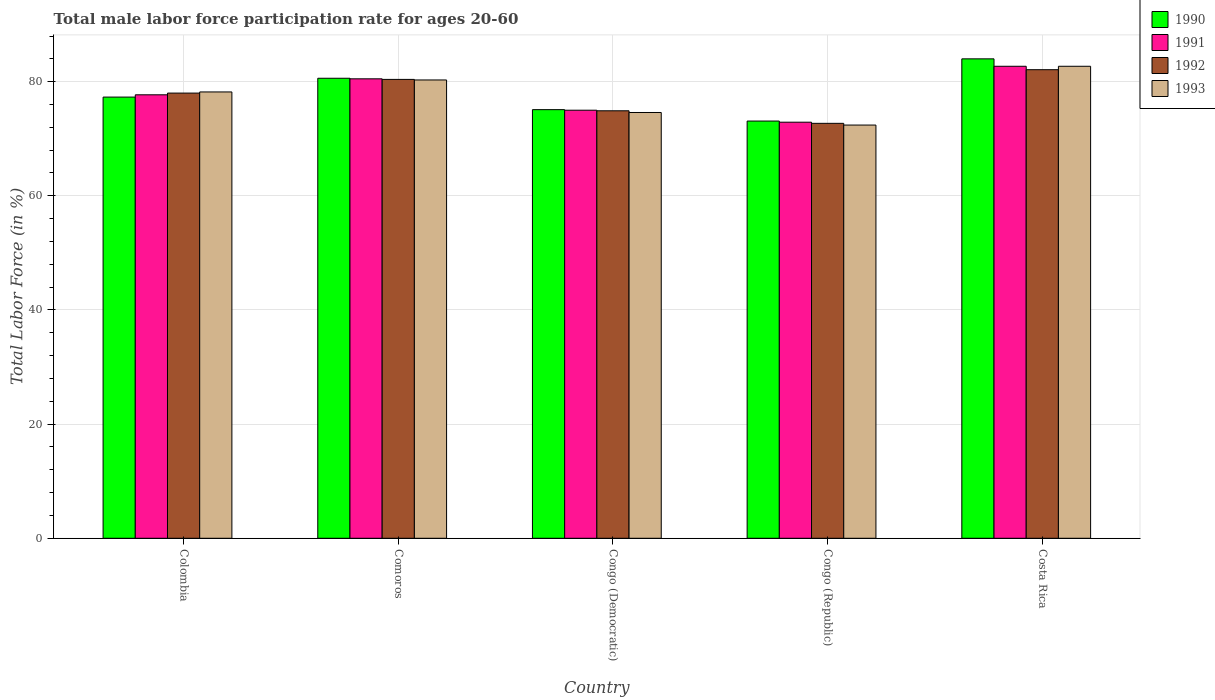How many different coloured bars are there?
Your answer should be compact. 4. How many groups of bars are there?
Your answer should be compact. 5. Are the number of bars on each tick of the X-axis equal?
Give a very brief answer. Yes. How many bars are there on the 2nd tick from the right?
Your response must be concise. 4. What is the male labor force participation rate in 1991 in Comoros?
Offer a terse response. 80.5. Across all countries, what is the minimum male labor force participation rate in 1990?
Offer a terse response. 73.1. In which country was the male labor force participation rate in 1992 maximum?
Give a very brief answer. Costa Rica. In which country was the male labor force participation rate in 1993 minimum?
Your answer should be very brief. Congo (Republic). What is the total male labor force participation rate in 1991 in the graph?
Keep it short and to the point. 388.8. What is the difference between the male labor force participation rate in 1991 in Comoros and that in Costa Rica?
Keep it short and to the point. -2.2. What is the difference between the male labor force participation rate in 1993 in Congo (Democratic) and the male labor force participation rate in 1992 in Colombia?
Your answer should be very brief. -3.4. What is the average male labor force participation rate in 1990 per country?
Make the answer very short. 78.02. In how many countries, is the male labor force participation rate in 1992 greater than 4 %?
Give a very brief answer. 5. What is the ratio of the male labor force participation rate in 1990 in Comoros to that in Congo (Republic)?
Your response must be concise. 1.1. Is the male labor force participation rate in 1993 in Colombia less than that in Congo (Democratic)?
Give a very brief answer. No. What is the difference between the highest and the second highest male labor force participation rate in 1990?
Keep it short and to the point. -3.4. What is the difference between the highest and the lowest male labor force participation rate in 1990?
Provide a short and direct response. 10.9. In how many countries, is the male labor force participation rate in 1991 greater than the average male labor force participation rate in 1991 taken over all countries?
Keep it short and to the point. 2. Is the sum of the male labor force participation rate in 1990 in Colombia and Congo (Democratic) greater than the maximum male labor force participation rate in 1992 across all countries?
Offer a terse response. Yes. Is it the case that in every country, the sum of the male labor force participation rate in 1990 and male labor force participation rate in 1993 is greater than the male labor force participation rate in 1992?
Make the answer very short. Yes. How many bars are there?
Your answer should be very brief. 20. Are all the bars in the graph horizontal?
Ensure brevity in your answer.  No. What is the difference between two consecutive major ticks on the Y-axis?
Your response must be concise. 20. Are the values on the major ticks of Y-axis written in scientific E-notation?
Your answer should be very brief. No. Where does the legend appear in the graph?
Keep it short and to the point. Top right. How many legend labels are there?
Your answer should be compact. 4. How are the legend labels stacked?
Provide a short and direct response. Vertical. What is the title of the graph?
Give a very brief answer. Total male labor force participation rate for ages 20-60. What is the label or title of the X-axis?
Provide a short and direct response. Country. What is the Total Labor Force (in %) in 1990 in Colombia?
Give a very brief answer. 77.3. What is the Total Labor Force (in %) in 1991 in Colombia?
Your answer should be very brief. 77.7. What is the Total Labor Force (in %) of 1992 in Colombia?
Your answer should be very brief. 78. What is the Total Labor Force (in %) of 1993 in Colombia?
Ensure brevity in your answer.  78.2. What is the Total Labor Force (in %) in 1990 in Comoros?
Keep it short and to the point. 80.6. What is the Total Labor Force (in %) in 1991 in Comoros?
Provide a short and direct response. 80.5. What is the Total Labor Force (in %) of 1992 in Comoros?
Keep it short and to the point. 80.4. What is the Total Labor Force (in %) of 1993 in Comoros?
Give a very brief answer. 80.3. What is the Total Labor Force (in %) of 1990 in Congo (Democratic)?
Ensure brevity in your answer.  75.1. What is the Total Labor Force (in %) of 1991 in Congo (Democratic)?
Offer a terse response. 75. What is the Total Labor Force (in %) of 1992 in Congo (Democratic)?
Your response must be concise. 74.9. What is the Total Labor Force (in %) of 1993 in Congo (Democratic)?
Provide a succinct answer. 74.6. What is the Total Labor Force (in %) of 1990 in Congo (Republic)?
Provide a succinct answer. 73.1. What is the Total Labor Force (in %) in 1991 in Congo (Republic)?
Offer a terse response. 72.9. What is the Total Labor Force (in %) in 1992 in Congo (Republic)?
Offer a very short reply. 72.7. What is the Total Labor Force (in %) of 1993 in Congo (Republic)?
Provide a succinct answer. 72.4. What is the Total Labor Force (in %) of 1991 in Costa Rica?
Provide a short and direct response. 82.7. What is the Total Labor Force (in %) of 1992 in Costa Rica?
Give a very brief answer. 82.1. What is the Total Labor Force (in %) in 1993 in Costa Rica?
Your answer should be very brief. 82.7. Across all countries, what is the maximum Total Labor Force (in %) of 1990?
Offer a very short reply. 84. Across all countries, what is the maximum Total Labor Force (in %) in 1991?
Offer a terse response. 82.7. Across all countries, what is the maximum Total Labor Force (in %) in 1992?
Provide a succinct answer. 82.1. Across all countries, what is the maximum Total Labor Force (in %) in 1993?
Keep it short and to the point. 82.7. Across all countries, what is the minimum Total Labor Force (in %) in 1990?
Make the answer very short. 73.1. Across all countries, what is the minimum Total Labor Force (in %) in 1991?
Provide a succinct answer. 72.9. Across all countries, what is the minimum Total Labor Force (in %) of 1992?
Keep it short and to the point. 72.7. Across all countries, what is the minimum Total Labor Force (in %) in 1993?
Provide a short and direct response. 72.4. What is the total Total Labor Force (in %) in 1990 in the graph?
Offer a very short reply. 390.1. What is the total Total Labor Force (in %) in 1991 in the graph?
Give a very brief answer. 388.8. What is the total Total Labor Force (in %) of 1992 in the graph?
Ensure brevity in your answer.  388.1. What is the total Total Labor Force (in %) in 1993 in the graph?
Offer a terse response. 388.2. What is the difference between the Total Labor Force (in %) in 1990 in Colombia and that in Comoros?
Give a very brief answer. -3.3. What is the difference between the Total Labor Force (in %) of 1992 in Colombia and that in Comoros?
Ensure brevity in your answer.  -2.4. What is the difference between the Total Labor Force (in %) in 1990 in Colombia and that in Congo (Democratic)?
Keep it short and to the point. 2.2. What is the difference between the Total Labor Force (in %) in 1991 in Colombia and that in Congo (Democratic)?
Your answer should be compact. 2.7. What is the difference between the Total Labor Force (in %) in 1992 in Colombia and that in Congo (Democratic)?
Provide a succinct answer. 3.1. What is the difference between the Total Labor Force (in %) of 1990 in Colombia and that in Congo (Republic)?
Your answer should be compact. 4.2. What is the difference between the Total Labor Force (in %) in 1990 in Comoros and that in Congo (Democratic)?
Provide a succinct answer. 5.5. What is the difference between the Total Labor Force (in %) in 1991 in Comoros and that in Congo (Democratic)?
Provide a short and direct response. 5.5. What is the difference between the Total Labor Force (in %) in 1992 in Comoros and that in Congo (Democratic)?
Give a very brief answer. 5.5. What is the difference between the Total Labor Force (in %) of 1993 in Comoros and that in Congo (Democratic)?
Make the answer very short. 5.7. What is the difference between the Total Labor Force (in %) in 1992 in Comoros and that in Congo (Republic)?
Provide a short and direct response. 7.7. What is the difference between the Total Labor Force (in %) of 1990 in Comoros and that in Costa Rica?
Offer a very short reply. -3.4. What is the difference between the Total Labor Force (in %) in 1992 in Comoros and that in Costa Rica?
Your answer should be very brief. -1.7. What is the difference between the Total Labor Force (in %) of 1990 in Congo (Democratic) and that in Congo (Republic)?
Your response must be concise. 2. What is the difference between the Total Labor Force (in %) of 1992 in Congo (Democratic) and that in Congo (Republic)?
Your answer should be very brief. 2.2. What is the difference between the Total Labor Force (in %) of 1991 in Congo (Democratic) and that in Costa Rica?
Make the answer very short. -7.7. What is the difference between the Total Labor Force (in %) of 1992 in Congo (Democratic) and that in Costa Rica?
Your answer should be compact. -7.2. What is the difference between the Total Labor Force (in %) of 1993 in Congo (Democratic) and that in Costa Rica?
Keep it short and to the point. -8.1. What is the difference between the Total Labor Force (in %) of 1991 in Congo (Republic) and that in Costa Rica?
Your answer should be compact. -9.8. What is the difference between the Total Labor Force (in %) of 1992 in Congo (Republic) and that in Costa Rica?
Provide a succinct answer. -9.4. What is the difference between the Total Labor Force (in %) of 1993 in Congo (Republic) and that in Costa Rica?
Make the answer very short. -10.3. What is the difference between the Total Labor Force (in %) in 1990 in Colombia and the Total Labor Force (in %) in 1991 in Comoros?
Offer a very short reply. -3.2. What is the difference between the Total Labor Force (in %) of 1990 in Colombia and the Total Labor Force (in %) of 1992 in Comoros?
Offer a terse response. -3.1. What is the difference between the Total Labor Force (in %) in 1992 in Colombia and the Total Labor Force (in %) in 1993 in Comoros?
Make the answer very short. -2.3. What is the difference between the Total Labor Force (in %) of 1990 in Colombia and the Total Labor Force (in %) of 1992 in Congo (Democratic)?
Ensure brevity in your answer.  2.4. What is the difference between the Total Labor Force (in %) in 1990 in Colombia and the Total Labor Force (in %) in 1993 in Congo (Democratic)?
Your answer should be compact. 2.7. What is the difference between the Total Labor Force (in %) of 1991 in Colombia and the Total Labor Force (in %) of 1993 in Congo (Democratic)?
Provide a succinct answer. 3.1. What is the difference between the Total Labor Force (in %) of 1990 in Colombia and the Total Labor Force (in %) of 1993 in Congo (Republic)?
Ensure brevity in your answer.  4.9. What is the difference between the Total Labor Force (in %) of 1991 in Colombia and the Total Labor Force (in %) of 1992 in Congo (Republic)?
Offer a very short reply. 5. What is the difference between the Total Labor Force (in %) of 1991 in Colombia and the Total Labor Force (in %) of 1993 in Congo (Republic)?
Ensure brevity in your answer.  5.3. What is the difference between the Total Labor Force (in %) in 1990 in Colombia and the Total Labor Force (in %) in 1992 in Costa Rica?
Your answer should be very brief. -4.8. What is the difference between the Total Labor Force (in %) of 1991 in Colombia and the Total Labor Force (in %) of 1993 in Costa Rica?
Make the answer very short. -5. What is the difference between the Total Labor Force (in %) in 1992 in Colombia and the Total Labor Force (in %) in 1993 in Costa Rica?
Your answer should be very brief. -4.7. What is the difference between the Total Labor Force (in %) in 1990 in Comoros and the Total Labor Force (in %) in 1991 in Congo (Democratic)?
Provide a short and direct response. 5.6. What is the difference between the Total Labor Force (in %) of 1990 in Comoros and the Total Labor Force (in %) of 1993 in Congo (Democratic)?
Provide a short and direct response. 6. What is the difference between the Total Labor Force (in %) of 1991 in Comoros and the Total Labor Force (in %) of 1992 in Congo (Democratic)?
Keep it short and to the point. 5.6. What is the difference between the Total Labor Force (in %) of 1991 in Comoros and the Total Labor Force (in %) of 1993 in Congo (Democratic)?
Provide a short and direct response. 5.9. What is the difference between the Total Labor Force (in %) of 1992 in Comoros and the Total Labor Force (in %) of 1993 in Congo (Democratic)?
Your response must be concise. 5.8. What is the difference between the Total Labor Force (in %) in 1990 in Comoros and the Total Labor Force (in %) in 1993 in Congo (Republic)?
Provide a succinct answer. 8.2. What is the difference between the Total Labor Force (in %) in 1992 in Comoros and the Total Labor Force (in %) in 1993 in Congo (Republic)?
Make the answer very short. 8. What is the difference between the Total Labor Force (in %) of 1991 in Comoros and the Total Labor Force (in %) of 1993 in Costa Rica?
Your response must be concise. -2.2. What is the difference between the Total Labor Force (in %) of 1992 in Comoros and the Total Labor Force (in %) of 1993 in Costa Rica?
Offer a terse response. -2.3. What is the difference between the Total Labor Force (in %) in 1990 in Congo (Democratic) and the Total Labor Force (in %) in 1992 in Congo (Republic)?
Your answer should be very brief. 2.4. What is the difference between the Total Labor Force (in %) in 1990 in Congo (Democratic) and the Total Labor Force (in %) in 1993 in Congo (Republic)?
Your answer should be very brief. 2.7. What is the difference between the Total Labor Force (in %) of 1991 in Congo (Democratic) and the Total Labor Force (in %) of 1992 in Congo (Republic)?
Your answer should be very brief. 2.3. What is the difference between the Total Labor Force (in %) in 1991 in Congo (Democratic) and the Total Labor Force (in %) in 1993 in Congo (Republic)?
Offer a very short reply. 2.6. What is the difference between the Total Labor Force (in %) of 1990 in Congo (Democratic) and the Total Labor Force (in %) of 1992 in Costa Rica?
Provide a short and direct response. -7. What is the difference between the Total Labor Force (in %) in 1990 in Congo (Democratic) and the Total Labor Force (in %) in 1993 in Costa Rica?
Give a very brief answer. -7.6. What is the difference between the Total Labor Force (in %) in 1991 in Congo (Democratic) and the Total Labor Force (in %) in 1992 in Costa Rica?
Keep it short and to the point. -7.1. What is the difference between the Total Labor Force (in %) of 1991 in Congo (Democratic) and the Total Labor Force (in %) of 1993 in Costa Rica?
Provide a short and direct response. -7.7. What is the difference between the Total Labor Force (in %) in 1992 in Congo (Democratic) and the Total Labor Force (in %) in 1993 in Costa Rica?
Keep it short and to the point. -7.8. What is the difference between the Total Labor Force (in %) of 1990 in Congo (Republic) and the Total Labor Force (in %) of 1992 in Costa Rica?
Give a very brief answer. -9. What is the difference between the Total Labor Force (in %) in 1990 in Congo (Republic) and the Total Labor Force (in %) in 1993 in Costa Rica?
Offer a terse response. -9.6. What is the average Total Labor Force (in %) of 1990 per country?
Ensure brevity in your answer.  78.02. What is the average Total Labor Force (in %) in 1991 per country?
Your response must be concise. 77.76. What is the average Total Labor Force (in %) of 1992 per country?
Provide a short and direct response. 77.62. What is the average Total Labor Force (in %) of 1993 per country?
Offer a terse response. 77.64. What is the difference between the Total Labor Force (in %) in 1991 and Total Labor Force (in %) in 1993 in Colombia?
Provide a short and direct response. -0.5. What is the difference between the Total Labor Force (in %) in 1990 and Total Labor Force (in %) in 1991 in Comoros?
Your answer should be compact. 0.1. What is the difference between the Total Labor Force (in %) in 1990 and Total Labor Force (in %) in 1993 in Comoros?
Your answer should be compact. 0.3. What is the difference between the Total Labor Force (in %) of 1990 and Total Labor Force (in %) of 1991 in Congo (Democratic)?
Your answer should be compact. 0.1. What is the difference between the Total Labor Force (in %) of 1990 and Total Labor Force (in %) of 1992 in Congo (Democratic)?
Ensure brevity in your answer.  0.2. What is the difference between the Total Labor Force (in %) in 1990 and Total Labor Force (in %) in 1993 in Congo (Democratic)?
Make the answer very short. 0.5. What is the difference between the Total Labor Force (in %) of 1991 and Total Labor Force (in %) of 1992 in Congo (Democratic)?
Give a very brief answer. 0.1. What is the difference between the Total Labor Force (in %) of 1990 and Total Labor Force (in %) of 1991 in Congo (Republic)?
Give a very brief answer. 0.2. What is the difference between the Total Labor Force (in %) of 1990 and Total Labor Force (in %) of 1993 in Congo (Republic)?
Keep it short and to the point. 0.7. What is the difference between the Total Labor Force (in %) in 1991 and Total Labor Force (in %) in 1993 in Congo (Republic)?
Keep it short and to the point. 0.5. What is the difference between the Total Labor Force (in %) in 1992 and Total Labor Force (in %) in 1993 in Congo (Republic)?
Your answer should be compact. 0.3. What is the difference between the Total Labor Force (in %) of 1990 and Total Labor Force (in %) of 1991 in Costa Rica?
Make the answer very short. 1.3. What is the ratio of the Total Labor Force (in %) of 1990 in Colombia to that in Comoros?
Give a very brief answer. 0.96. What is the ratio of the Total Labor Force (in %) of 1991 in Colombia to that in Comoros?
Provide a succinct answer. 0.97. What is the ratio of the Total Labor Force (in %) in 1992 in Colombia to that in Comoros?
Keep it short and to the point. 0.97. What is the ratio of the Total Labor Force (in %) of 1993 in Colombia to that in Comoros?
Offer a very short reply. 0.97. What is the ratio of the Total Labor Force (in %) in 1990 in Colombia to that in Congo (Democratic)?
Provide a short and direct response. 1.03. What is the ratio of the Total Labor Force (in %) in 1991 in Colombia to that in Congo (Democratic)?
Your answer should be compact. 1.04. What is the ratio of the Total Labor Force (in %) of 1992 in Colombia to that in Congo (Democratic)?
Offer a very short reply. 1.04. What is the ratio of the Total Labor Force (in %) in 1993 in Colombia to that in Congo (Democratic)?
Offer a very short reply. 1.05. What is the ratio of the Total Labor Force (in %) in 1990 in Colombia to that in Congo (Republic)?
Provide a succinct answer. 1.06. What is the ratio of the Total Labor Force (in %) in 1991 in Colombia to that in Congo (Republic)?
Give a very brief answer. 1.07. What is the ratio of the Total Labor Force (in %) of 1992 in Colombia to that in Congo (Republic)?
Give a very brief answer. 1.07. What is the ratio of the Total Labor Force (in %) of 1993 in Colombia to that in Congo (Republic)?
Offer a terse response. 1.08. What is the ratio of the Total Labor Force (in %) in 1990 in Colombia to that in Costa Rica?
Keep it short and to the point. 0.92. What is the ratio of the Total Labor Force (in %) of 1991 in Colombia to that in Costa Rica?
Your answer should be compact. 0.94. What is the ratio of the Total Labor Force (in %) of 1992 in Colombia to that in Costa Rica?
Your answer should be compact. 0.95. What is the ratio of the Total Labor Force (in %) in 1993 in Colombia to that in Costa Rica?
Keep it short and to the point. 0.95. What is the ratio of the Total Labor Force (in %) of 1990 in Comoros to that in Congo (Democratic)?
Keep it short and to the point. 1.07. What is the ratio of the Total Labor Force (in %) in 1991 in Comoros to that in Congo (Democratic)?
Offer a terse response. 1.07. What is the ratio of the Total Labor Force (in %) in 1992 in Comoros to that in Congo (Democratic)?
Your response must be concise. 1.07. What is the ratio of the Total Labor Force (in %) in 1993 in Comoros to that in Congo (Democratic)?
Provide a succinct answer. 1.08. What is the ratio of the Total Labor Force (in %) in 1990 in Comoros to that in Congo (Republic)?
Provide a short and direct response. 1.1. What is the ratio of the Total Labor Force (in %) in 1991 in Comoros to that in Congo (Republic)?
Provide a succinct answer. 1.1. What is the ratio of the Total Labor Force (in %) of 1992 in Comoros to that in Congo (Republic)?
Keep it short and to the point. 1.11. What is the ratio of the Total Labor Force (in %) in 1993 in Comoros to that in Congo (Republic)?
Your answer should be compact. 1.11. What is the ratio of the Total Labor Force (in %) in 1990 in Comoros to that in Costa Rica?
Your answer should be very brief. 0.96. What is the ratio of the Total Labor Force (in %) in 1991 in Comoros to that in Costa Rica?
Give a very brief answer. 0.97. What is the ratio of the Total Labor Force (in %) in 1992 in Comoros to that in Costa Rica?
Ensure brevity in your answer.  0.98. What is the ratio of the Total Labor Force (in %) of 1993 in Comoros to that in Costa Rica?
Offer a terse response. 0.97. What is the ratio of the Total Labor Force (in %) of 1990 in Congo (Democratic) to that in Congo (Republic)?
Keep it short and to the point. 1.03. What is the ratio of the Total Labor Force (in %) in 1991 in Congo (Democratic) to that in Congo (Republic)?
Give a very brief answer. 1.03. What is the ratio of the Total Labor Force (in %) of 1992 in Congo (Democratic) to that in Congo (Republic)?
Make the answer very short. 1.03. What is the ratio of the Total Labor Force (in %) in 1993 in Congo (Democratic) to that in Congo (Republic)?
Give a very brief answer. 1.03. What is the ratio of the Total Labor Force (in %) of 1990 in Congo (Democratic) to that in Costa Rica?
Offer a terse response. 0.89. What is the ratio of the Total Labor Force (in %) in 1991 in Congo (Democratic) to that in Costa Rica?
Give a very brief answer. 0.91. What is the ratio of the Total Labor Force (in %) of 1992 in Congo (Democratic) to that in Costa Rica?
Your answer should be compact. 0.91. What is the ratio of the Total Labor Force (in %) in 1993 in Congo (Democratic) to that in Costa Rica?
Make the answer very short. 0.9. What is the ratio of the Total Labor Force (in %) of 1990 in Congo (Republic) to that in Costa Rica?
Give a very brief answer. 0.87. What is the ratio of the Total Labor Force (in %) in 1991 in Congo (Republic) to that in Costa Rica?
Your response must be concise. 0.88. What is the ratio of the Total Labor Force (in %) of 1992 in Congo (Republic) to that in Costa Rica?
Your response must be concise. 0.89. What is the ratio of the Total Labor Force (in %) of 1993 in Congo (Republic) to that in Costa Rica?
Offer a terse response. 0.88. What is the difference between the highest and the second highest Total Labor Force (in %) of 1990?
Your answer should be very brief. 3.4. What is the difference between the highest and the second highest Total Labor Force (in %) in 1991?
Provide a succinct answer. 2.2. What is the difference between the highest and the second highest Total Labor Force (in %) in 1992?
Your response must be concise. 1.7. What is the difference between the highest and the lowest Total Labor Force (in %) of 1990?
Make the answer very short. 10.9. What is the difference between the highest and the lowest Total Labor Force (in %) in 1993?
Offer a very short reply. 10.3. 